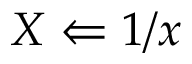Convert formula to latex. <formula><loc_0><loc_0><loc_500><loc_500>X \Leftarrow 1 / x</formula> 